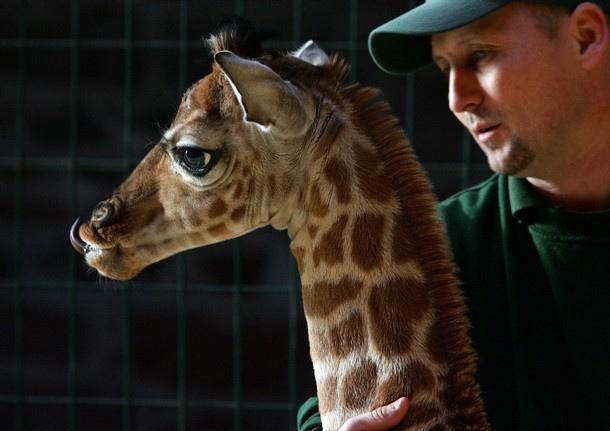How many people are in the photo?
Give a very brief answer. 1. 